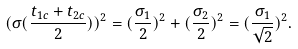<formula> <loc_0><loc_0><loc_500><loc_500>( \sigma ( \frac { t _ { 1 c } + t _ { 2 c } } { 2 } ) ) ^ { 2 } = ( \frac { \sigma _ { 1 } } { 2 } ) ^ { 2 } + ( \frac { \sigma _ { 2 } } { 2 } ) ^ { 2 } = ( \frac { \sigma _ { 1 } } { \sqrt { 2 } } ) ^ { 2 } .</formula> 